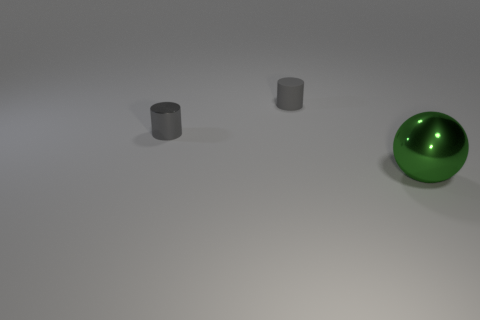How does the lighting in the image affect the appearance of the objects? The lighting in the image is soft and diffused, creating gentle shadows and subtle highlights. This illumination enhances the reflective quality of the green sphere, showcasing its shiny surface. For the cylindrical objects, the lighting emphasizes their three-dimensional form without creating harsh contrasts. 